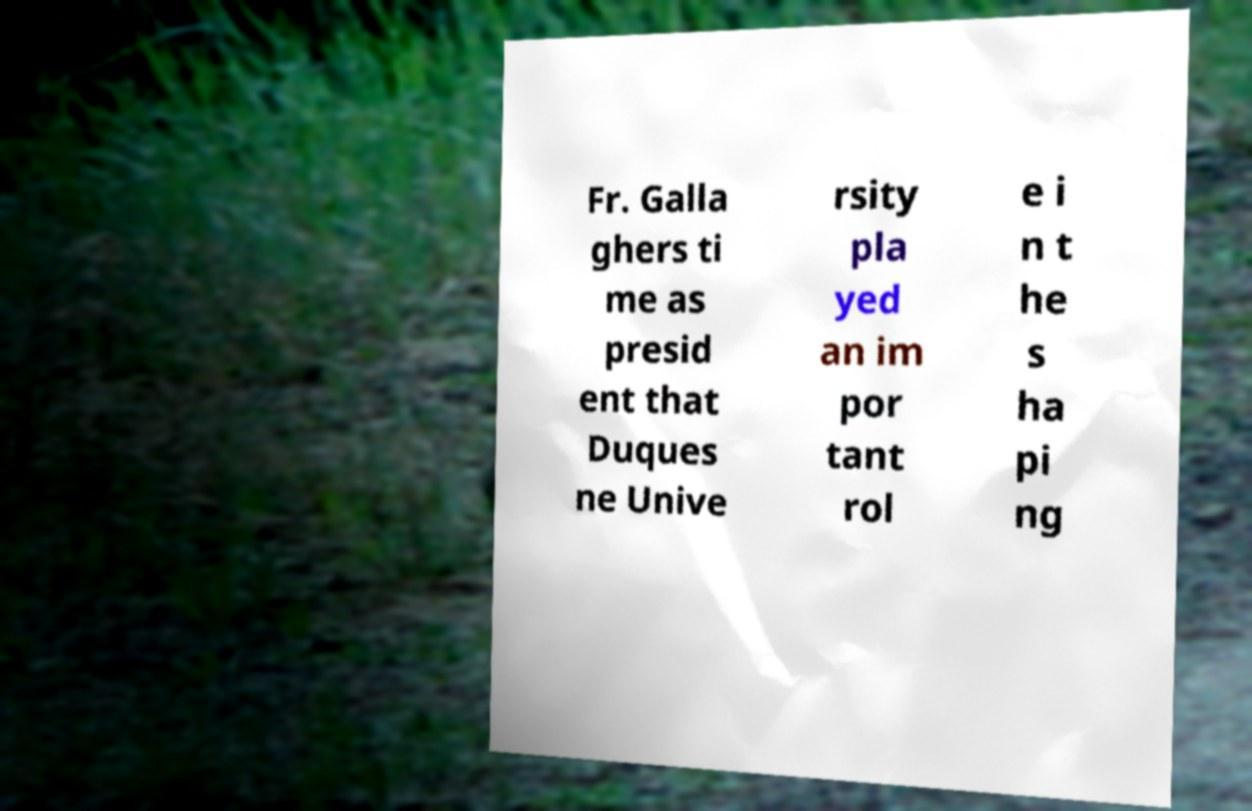For documentation purposes, I need the text within this image transcribed. Could you provide that? Fr. Galla ghers ti me as presid ent that Duques ne Unive rsity pla yed an im por tant rol e i n t he s ha pi ng 